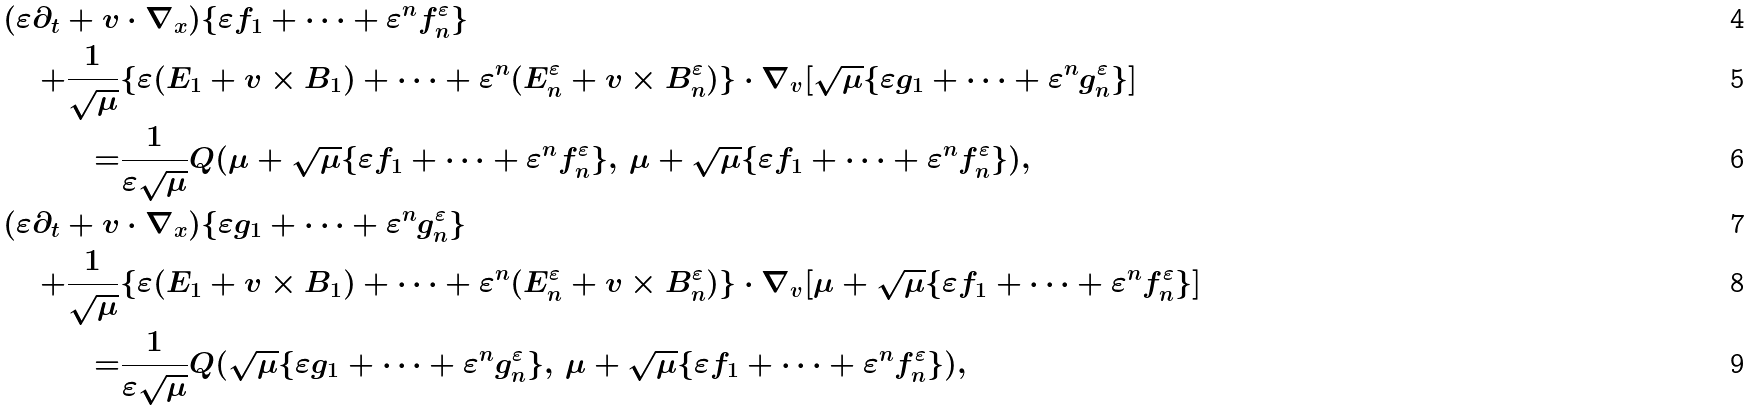Convert formula to latex. <formula><loc_0><loc_0><loc_500><loc_500>( \varepsilon \partial _ { t } + v & \cdot \nabla _ { x } ) \{ \varepsilon f _ { 1 } + \dots + \varepsilon ^ { n } f _ { n } ^ { \varepsilon } \} \\ + \frac { 1 } { \sqrt { \mu } } & \{ \varepsilon ( E _ { 1 } + v \times B _ { 1 } ) + \dots + \varepsilon ^ { n } ( E _ { n } ^ { \varepsilon } + v \times B _ { n } ^ { \varepsilon } ) \} \cdot \nabla _ { v } [ \sqrt { \mu } \{ \varepsilon g _ { 1 } + \dots + \varepsilon ^ { n } g _ { n } ^ { \varepsilon } \} ] \\ = & \frac { 1 } { \varepsilon \sqrt { \mu } } Q ( \mu + \sqrt { \mu } \{ \varepsilon f _ { 1 } + \dots + \varepsilon ^ { n } f _ { n } ^ { \varepsilon } \} , \, \mu + \sqrt { \mu } \{ \varepsilon f _ { 1 } + \dots + \varepsilon ^ { n } f _ { n } ^ { \varepsilon } \} ) , \\ \ ( \varepsilon \partial _ { t } + v & \cdot \nabla _ { x } ) \{ \varepsilon g _ { 1 } + \dots + \varepsilon ^ { n } g _ { n } ^ { \varepsilon } \} \\ + \frac { 1 } { \sqrt { \mu } } & \{ \varepsilon ( E _ { 1 } + v \times B _ { 1 } ) + \dots + \varepsilon ^ { n } ( E _ { n } ^ { \varepsilon } + v \times B _ { n } ^ { \varepsilon } ) \} \cdot \nabla _ { v } [ \mu + \sqrt { \mu } \{ \varepsilon f _ { 1 } + \dots + \varepsilon ^ { n } f _ { n } ^ { \varepsilon } \} ] \\ = & \frac { 1 } { \varepsilon \sqrt { \mu } } Q ( \sqrt { \mu } \{ \varepsilon g _ { 1 } + \dots + \varepsilon ^ { n } g _ { n } ^ { \varepsilon } \} , \, \mu + \sqrt { \mu } \{ \varepsilon f _ { 1 } + \dots + \varepsilon ^ { n } f _ { n } ^ { \varepsilon } \} ) ,</formula> 